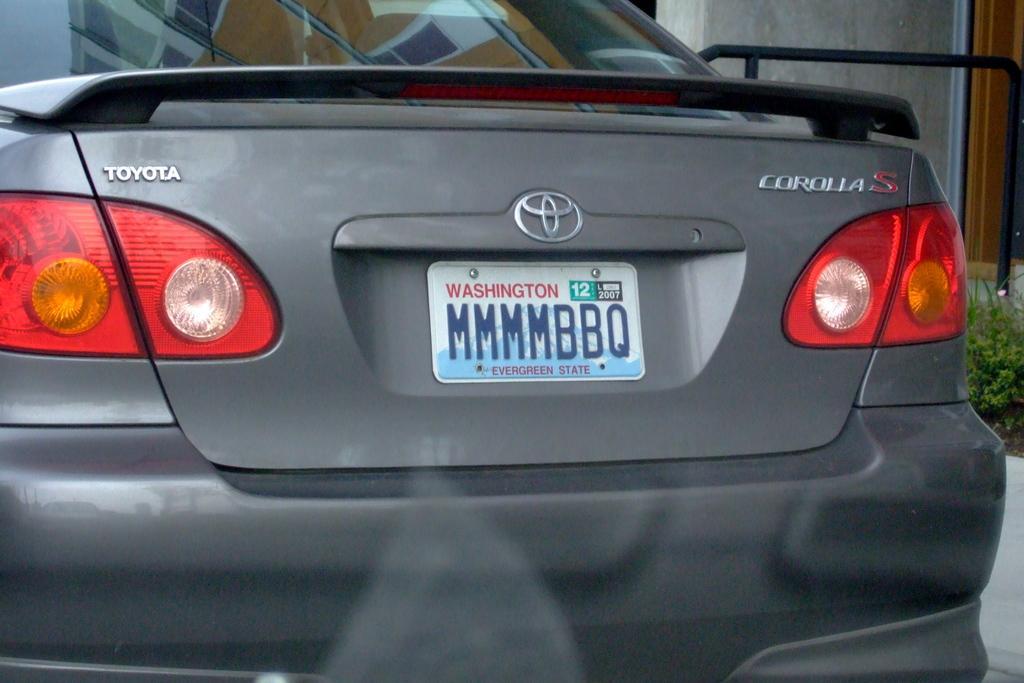How would you summarize this image in a sentence or two? In this picture we can see a car in the front, on the right side there is a plant, in the background we can see a wall. 